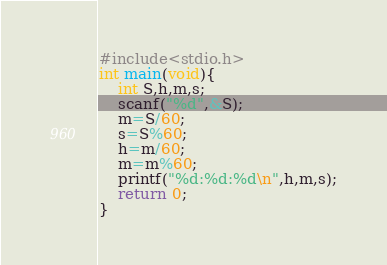<code> <loc_0><loc_0><loc_500><loc_500><_C_>#include<stdio.h>
int main(void){
    int S,h,m,s;
    scanf("%d",&S);
    m=S/60;
    s=S%60;
    h=m/60;
    m=m%60;
    printf("%d:%d:%d\n",h,m,s);
    return 0;
}
</code> 